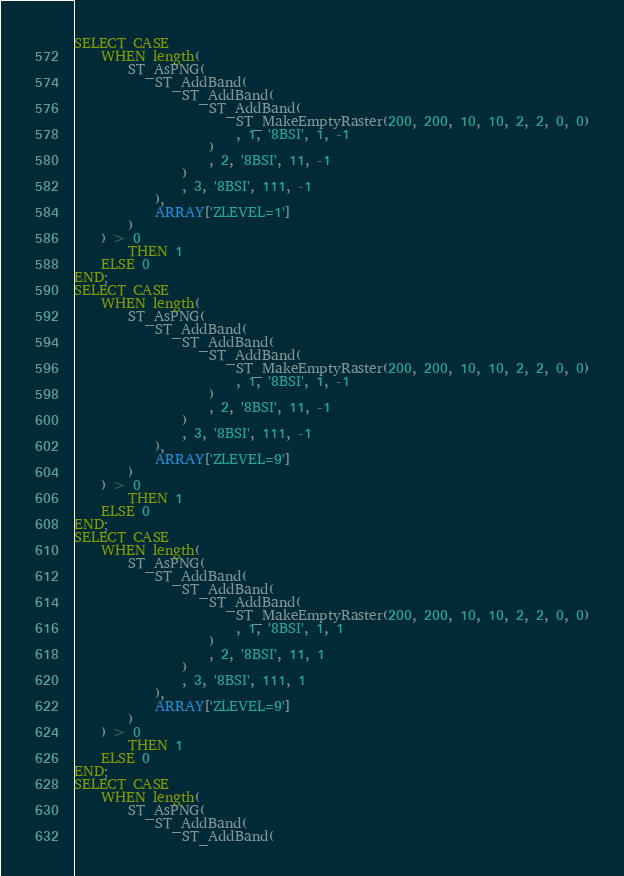Convert code to text. <code><loc_0><loc_0><loc_500><loc_500><_SQL_>SELECT CASE
	WHEN length(
		ST_AsPNG(
			ST_AddBand(
				ST_AddBand(
					ST_AddBand(
						ST_MakeEmptyRaster(200, 200, 10, 10, 2, 2, 0, 0)
						, 1, '8BSI', 1, -1
					)
					, 2, '8BSI', 11, -1
				)
				, 3, '8BSI', 111, -1
			),
			ARRAY['ZLEVEL=1']
		)
	) > 0
		THEN 1
	ELSE 0
END;
SELECT CASE
	WHEN length(
		ST_AsPNG(
			ST_AddBand(
				ST_AddBand(
					ST_AddBand(
						ST_MakeEmptyRaster(200, 200, 10, 10, 2, 2, 0, 0)
						, 1, '8BSI', 1, -1
					)
					, 2, '8BSI', 11, -1
				)
				, 3, '8BSI', 111, -1
			),
			ARRAY['ZLEVEL=9']
		)
	) > 0
		THEN 1
	ELSE 0
END;
SELECT CASE
	WHEN length(
		ST_AsPNG(
			ST_AddBand(
				ST_AddBand(
					ST_AddBand(
						ST_MakeEmptyRaster(200, 200, 10, 10, 2, 2, 0, 0)
						, 1, '8BSI', 1, 1
					)
					, 2, '8BSI', 11, 1
				)
				, 3, '8BSI', 111, 1
			),
			ARRAY['ZLEVEL=9']
		)
	) > 0
		THEN 1
	ELSE 0
END;
SELECT CASE
	WHEN length(
		ST_AsPNG(
			ST_AddBand(
				ST_AddBand(</code> 